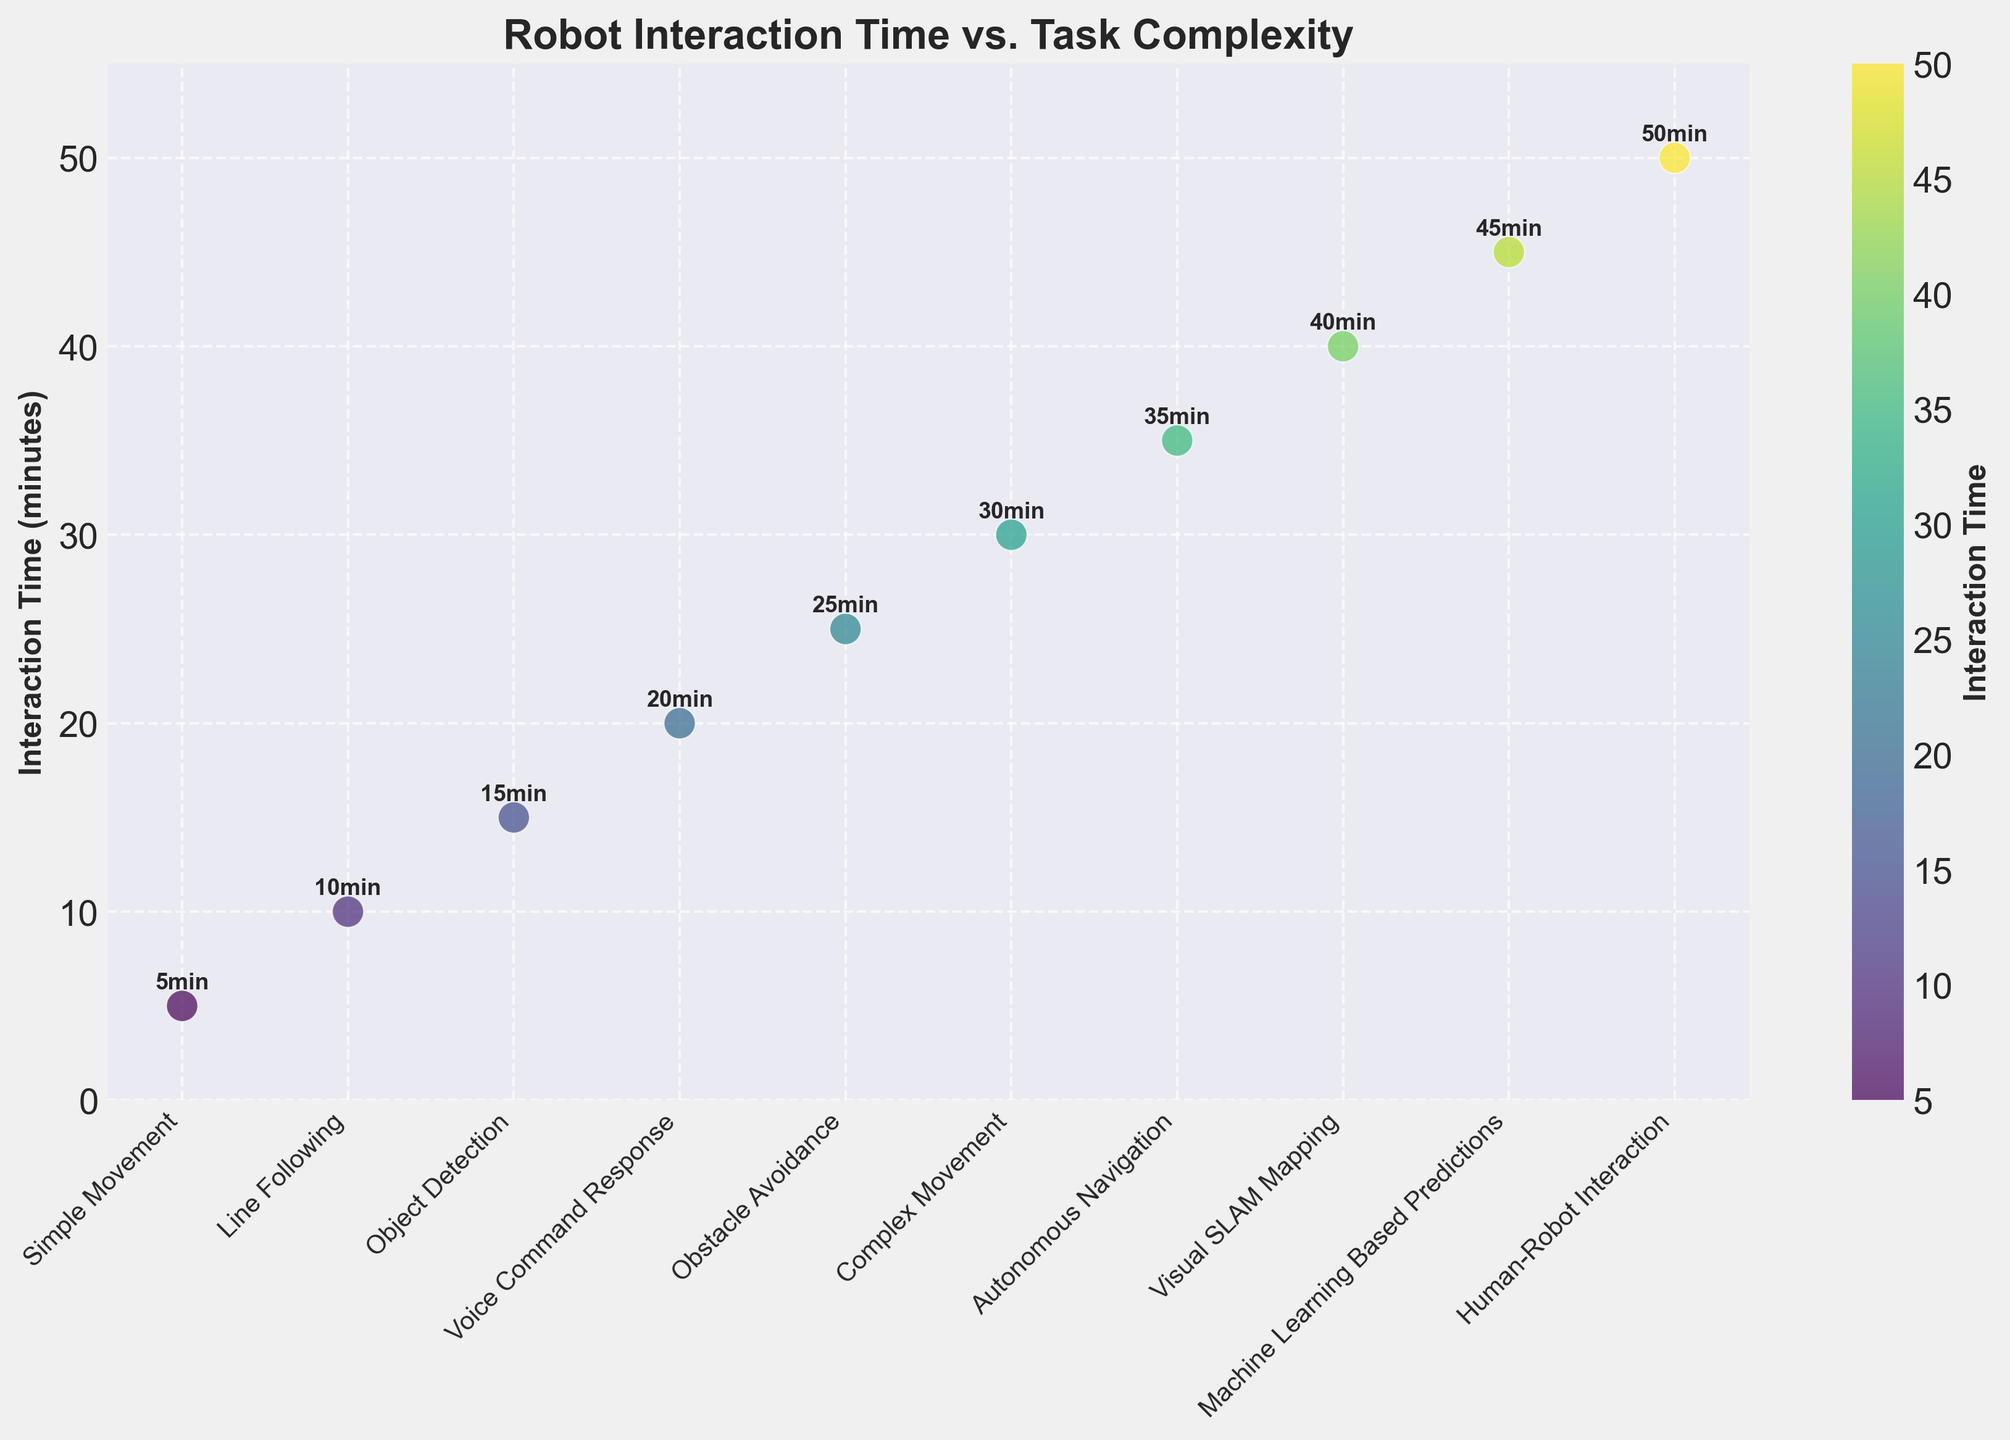What's the title of the figure? The title of the figure is usually found at the top and sometimes in bold. Here, it states the overarching theme of the plot.
Answer: Robot Interaction Time vs. Task Complexity How many tasks are displayed on the x-axis? Count the number of unique tasks listed along the x-axis. Each tick represents a task.
Answer: 10 Which task has the highest interaction time? The color bar and the y-axis indicate interaction times. Look for the data point highest on the y-axis or refer to the colors from the color bar indicating higher values.
Answer: Human-Robot Interaction What is the y-axis label? The y-axis label is located vertically along the y-axis, often near the axis itself.
Answer: Interaction Time (minutes) Which two tasks have interaction times that differ by exactly 10 minutes? Examine the y-axis values of each task and find two tasks that have interaction times differing by 10.
Answer: Simple Movement and Line Following What is the average interaction time for all tasks? Sum the interaction times of all tasks and divide by the number of tasks. (5 + 10 + 15 + 20 + 25 + 30 + 35 + 40 + 45 + 50) / 10
Answer: 27.5 minutes Which task has a slightly lower interaction time than Autonomous Navigation? Locate Autonomous Navigation on the plot; then compare it to the tasks with a slightly lower interaction time visually or by reading the y-values.
Answer: Complex Movement By how much is the interaction time longer for Visual SLAM Mapping compared to Voice Command Response? Subtract the interaction time of Voice Command Response from the interaction time of Visual SLAM Mapping. 40 - 20
Answer: 20 minutes Among the tasks listed, which ones are clustered closely in terms of interaction time? Look for data points that are visually close to each other along the y-axis or references the color gradient indicating similar values.
Answer: Object Detection and Voice Command Response What does the color of the data points represent? The color is typically mapped to a variable in the color bar. Here, it represents the level of interaction time, based on the gradient from the color bar.
Answer: Interaction Time 